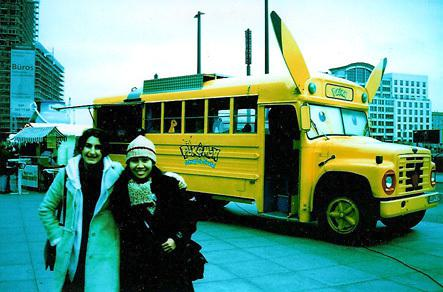Can you tell me about the environment around the bus? Certainly! The bus is parked in an urban setting with modern buildings in the background. It seems to be a public space, possibly a square or a wide street, where events or markets might be held, contributing to a lively atmosphere. 